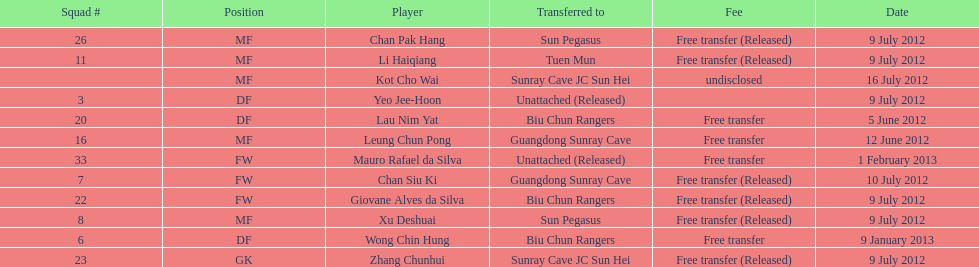Li haiqiang and xu deshuai both played which position? MF. 